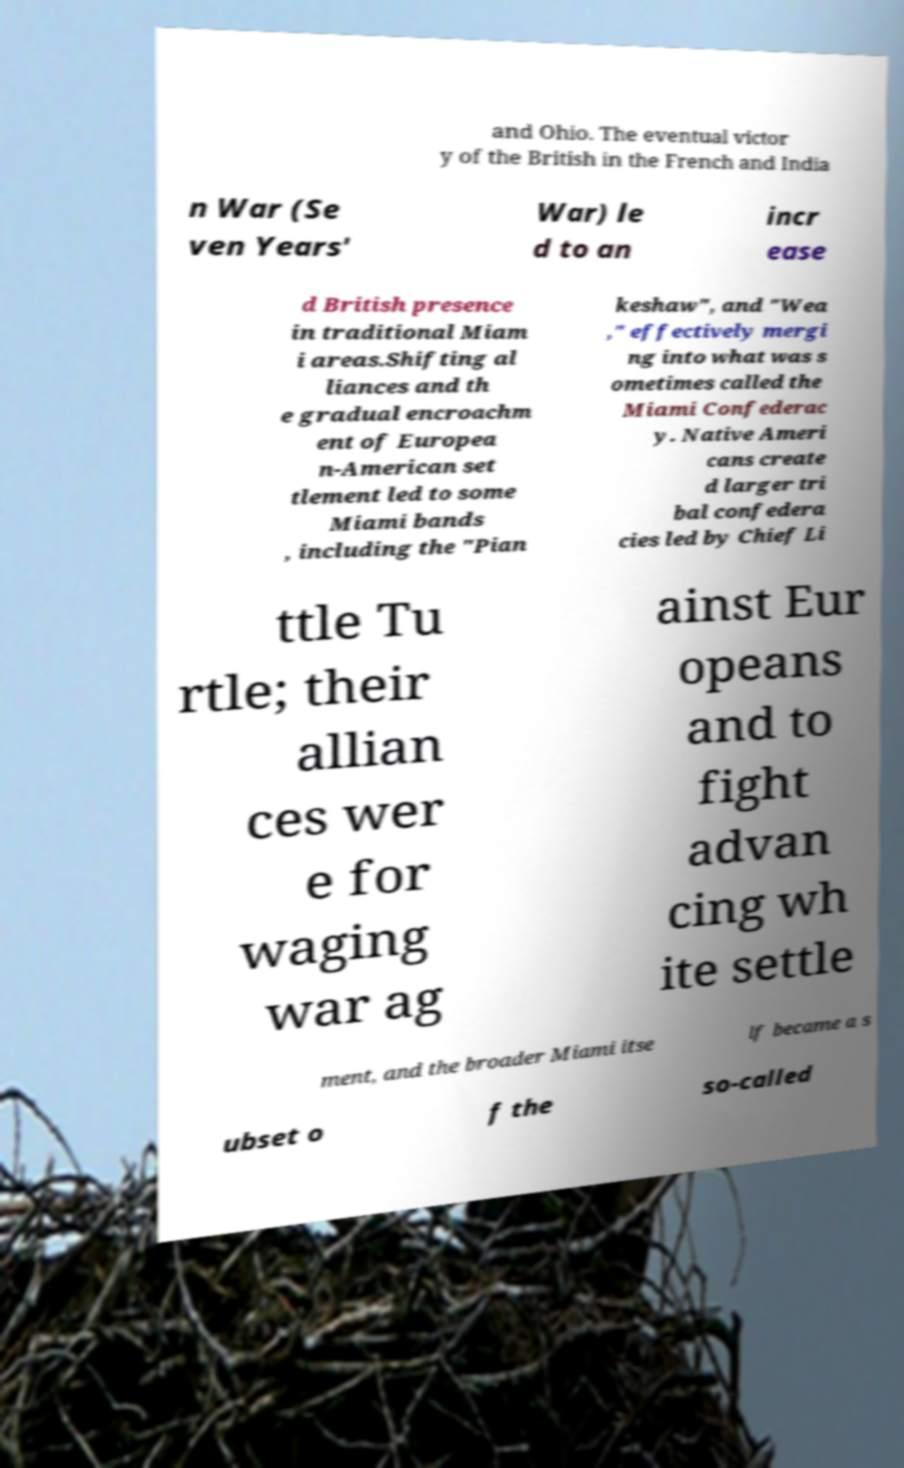Can you read and provide the text displayed in the image?This photo seems to have some interesting text. Can you extract and type it out for me? and Ohio. The eventual victor y of the British in the French and India n War (Se ven Years' War) le d to an incr ease d British presence in traditional Miam i areas.Shifting al liances and th e gradual encroachm ent of Europea n-American set tlement led to some Miami bands , including the "Pian keshaw", and "Wea ," effectively mergi ng into what was s ometimes called the Miami Confederac y. Native Ameri cans create d larger tri bal confedera cies led by Chief Li ttle Tu rtle; their allian ces wer e for waging war ag ainst Eur opeans and to fight advan cing wh ite settle ment, and the broader Miami itse lf became a s ubset o f the so-called 